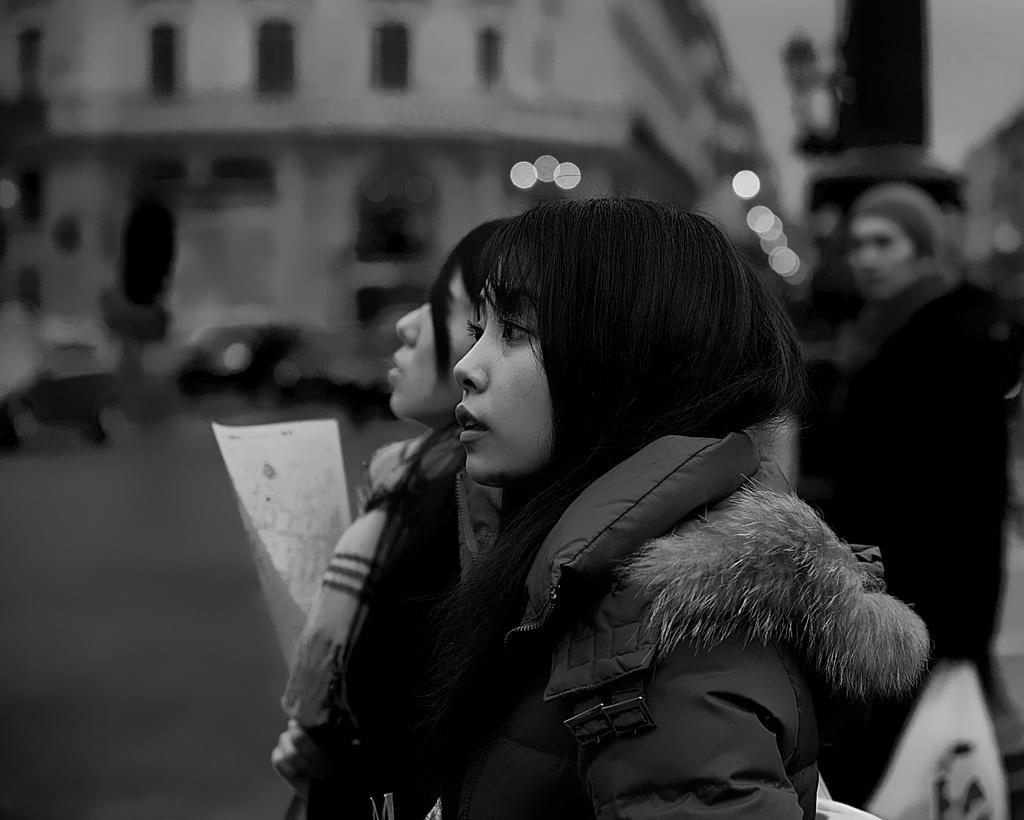Can you describe this image briefly? This is a black and white picture. I can see three persons, building, and there is blur background. 